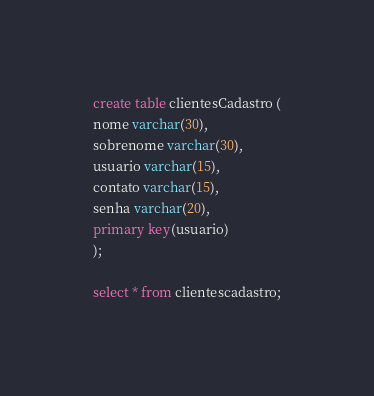Convert code to text. <code><loc_0><loc_0><loc_500><loc_500><_SQL_>create table clientesCadastro (
nome varchar(30),
sobrenome varchar(30),
usuario varchar(15),
contato varchar(15),
senha varchar(20),
primary key(usuario)
);

select * from clientescadastro;
</code> 